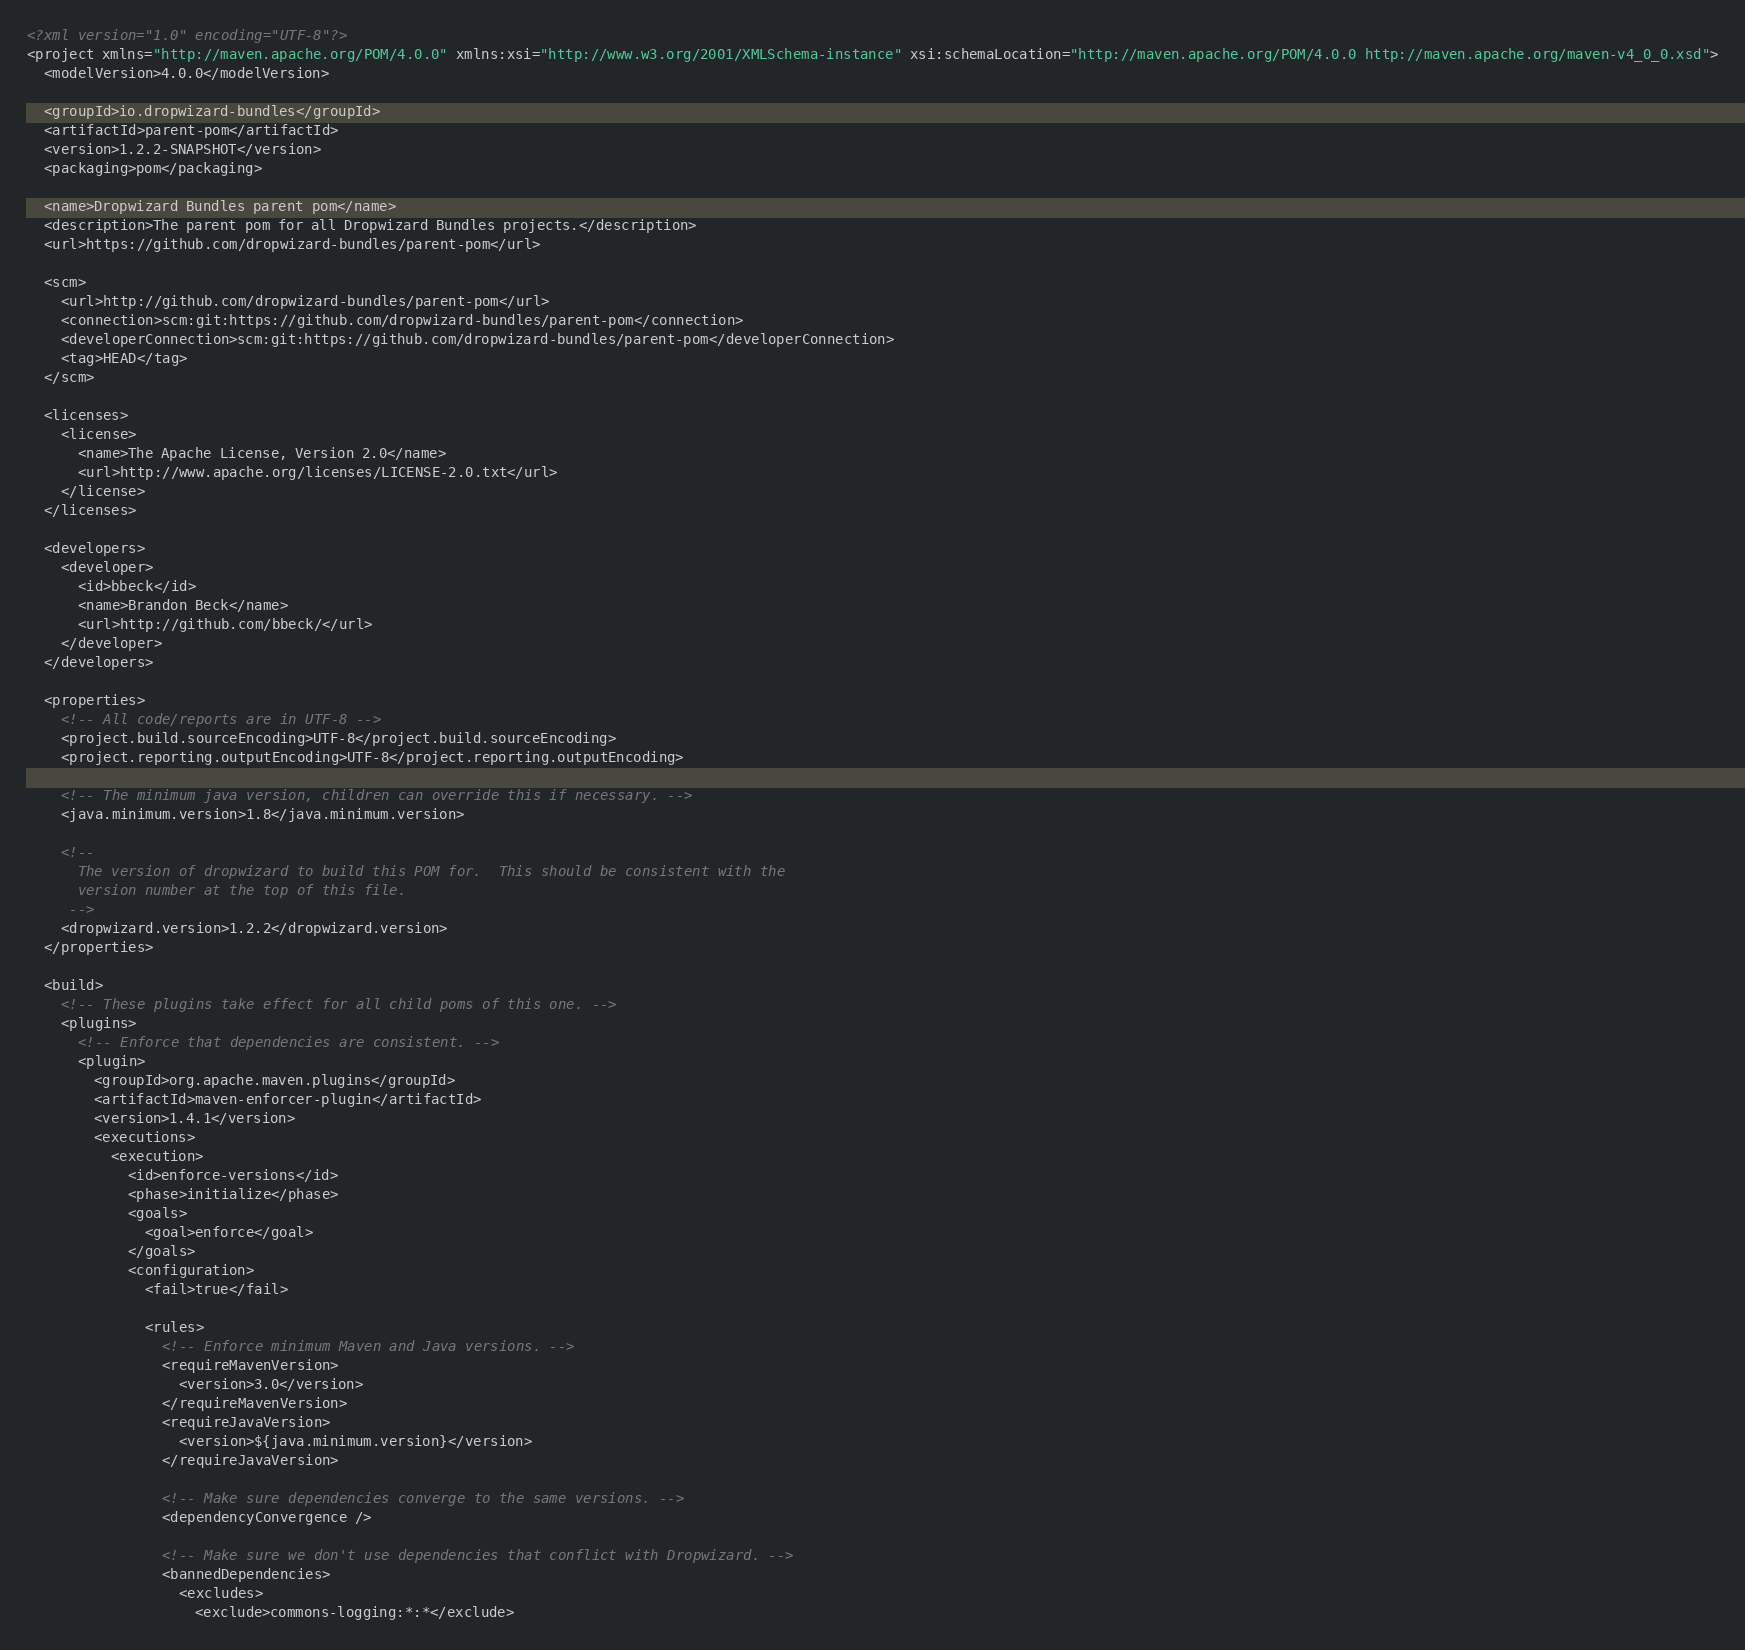Convert code to text. <code><loc_0><loc_0><loc_500><loc_500><_XML_><?xml version="1.0" encoding="UTF-8"?>
<project xmlns="http://maven.apache.org/POM/4.0.0" xmlns:xsi="http://www.w3.org/2001/XMLSchema-instance" xsi:schemaLocation="http://maven.apache.org/POM/4.0.0 http://maven.apache.org/maven-v4_0_0.xsd">
  <modelVersion>4.0.0</modelVersion>

  <groupId>io.dropwizard-bundles</groupId>
  <artifactId>parent-pom</artifactId>
  <version>1.2.2-SNAPSHOT</version>
  <packaging>pom</packaging>

  <name>Dropwizard Bundles parent pom</name>
  <description>The parent pom for all Dropwizard Bundles projects.</description>
  <url>https://github.com/dropwizard-bundles/parent-pom</url>

  <scm>
    <url>http://github.com/dropwizard-bundles/parent-pom</url>
    <connection>scm:git:https://github.com/dropwizard-bundles/parent-pom</connection>
    <developerConnection>scm:git:https://github.com/dropwizard-bundles/parent-pom</developerConnection>
    <tag>HEAD</tag>
  </scm>

  <licenses>
    <license>
      <name>The Apache License, Version 2.0</name>
      <url>http://www.apache.org/licenses/LICENSE-2.0.txt</url>
    </license>
  </licenses>

  <developers>
    <developer>
      <id>bbeck</id>
      <name>Brandon Beck</name>
      <url>http://github.com/bbeck/</url>
    </developer>
  </developers>

  <properties>
    <!-- All code/reports are in UTF-8 -->
    <project.build.sourceEncoding>UTF-8</project.build.sourceEncoding>
    <project.reporting.outputEncoding>UTF-8</project.reporting.outputEncoding>

    <!-- The minimum java version, children can override this if necessary. -->
    <java.minimum.version>1.8</java.minimum.version>

    <!--
      The version of dropwizard to build this POM for.  This should be consistent with the
      version number at the top of this file.
     -->
    <dropwizard.version>1.2.2</dropwizard.version>
  </properties>

  <build>
    <!-- These plugins take effect for all child poms of this one. -->
    <plugins>
      <!-- Enforce that dependencies are consistent. -->
      <plugin>
        <groupId>org.apache.maven.plugins</groupId>
        <artifactId>maven-enforcer-plugin</artifactId>
        <version>1.4.1</version>
        <executions>
          <execution>
            <id>enforce-versions</id>
            <phase>initialize</phase>
            <goals>
              <goal>enforce</goal>
            </goals>
            <configuration>
              <fail>true</fail>

              <rules>
                <!-- Enforce minimum Maven and Java versions. -->
                <requireMavenVersion>
                  <version>3.0</version>
                </requireMavenVersion>
                <requireJavaVersion>
                  <version>${java.minimum.version}</version>
                </requireJavaVersion>

                <!-- Make sure dependencies converge to the same versions. -->
                <dependencyConvergence />

                <!-- Make sure we don't use dependencies that conflict with Dropwizard. -->
                <bannedDependencies>
                  <excludes>
                    <exclude>commons-logging:*:*</exclude></code> 